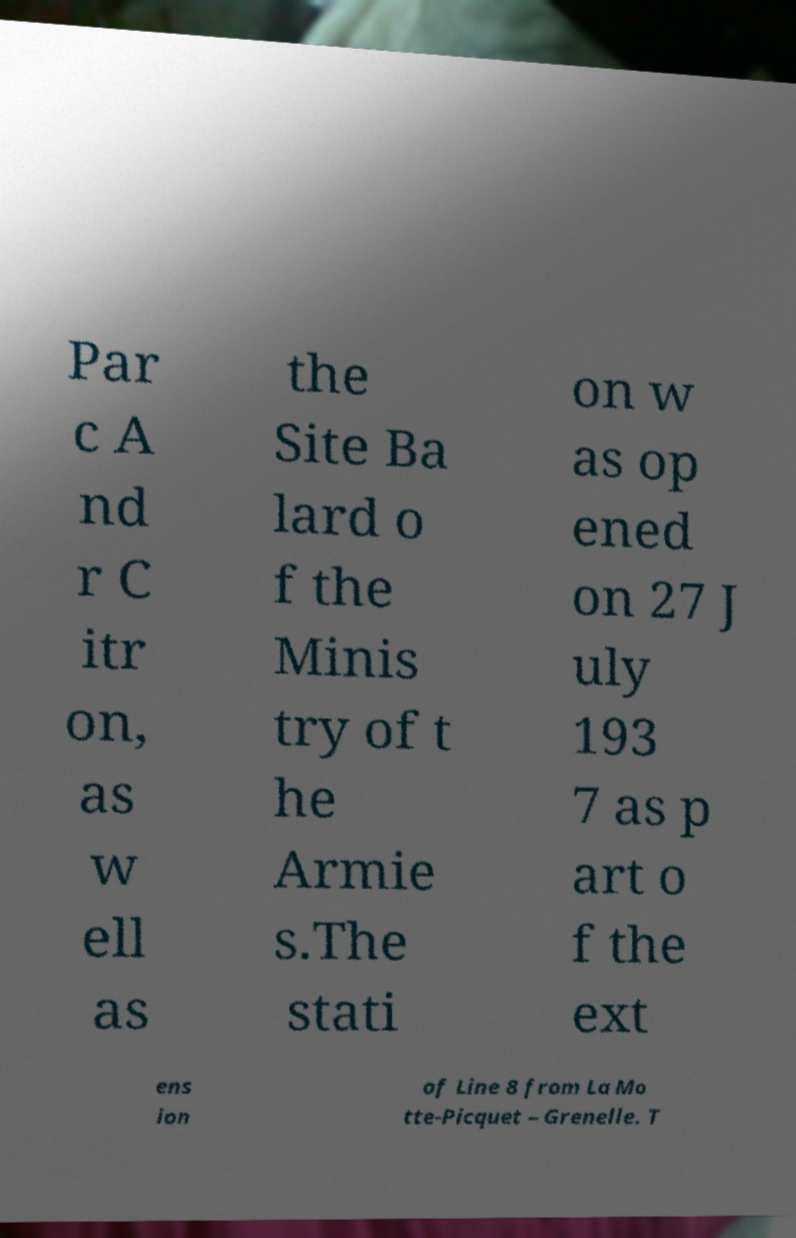Could you assist in decoding the text presented in this image and type it out clearly? Par c A nd r C itr on, as w ell as the Site Ba lard o f the Minis try of t he Armie s.The stati on w as op ened on 27 J uly 193 7 as p art o f the ext ens ion of Line 8 from La Mo tte-Picquet – Grenelle. T 